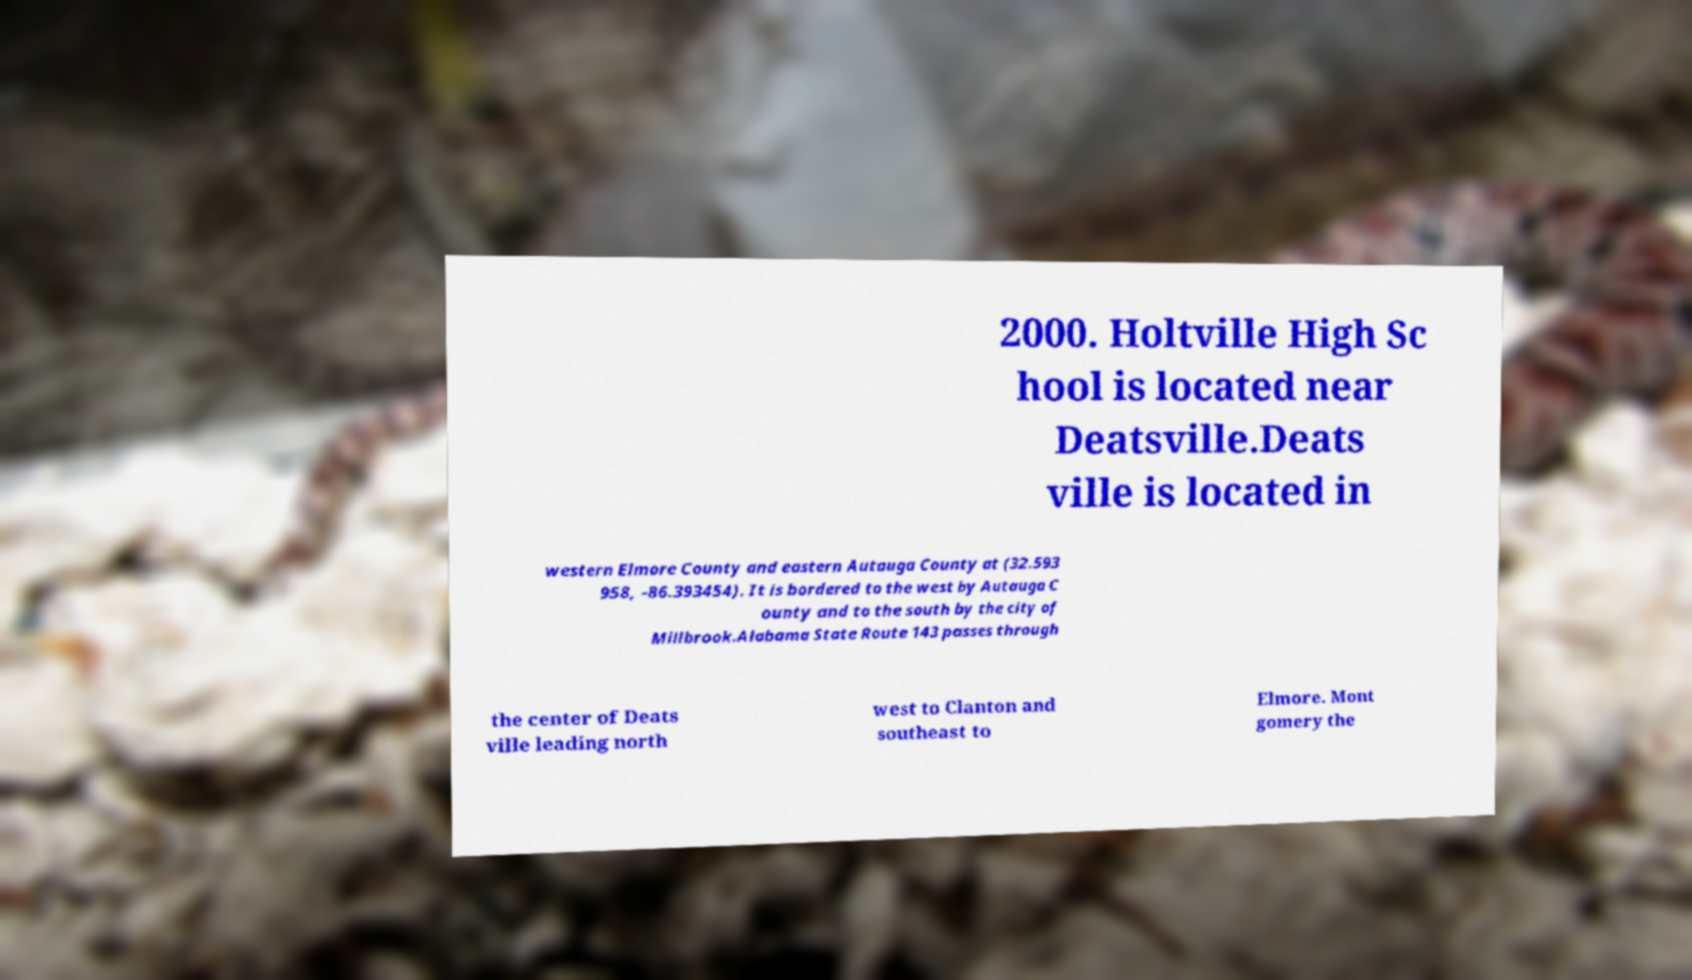Could you assist in decoding the text presented in this image and type it out clearly? 2000. Holtville High Sc hool is located near Deatsville.Deats ville is located in western Elmore County and eastern Autauga County at (32.593 958, -86.393454). It is bordered to the west by Autauga C ounty and to the south by the city of Millbrook.Alabama State Route 143 passes through the center of Deats ville leading north west to Clanton and southeast to Elmore. Mont gomery the 